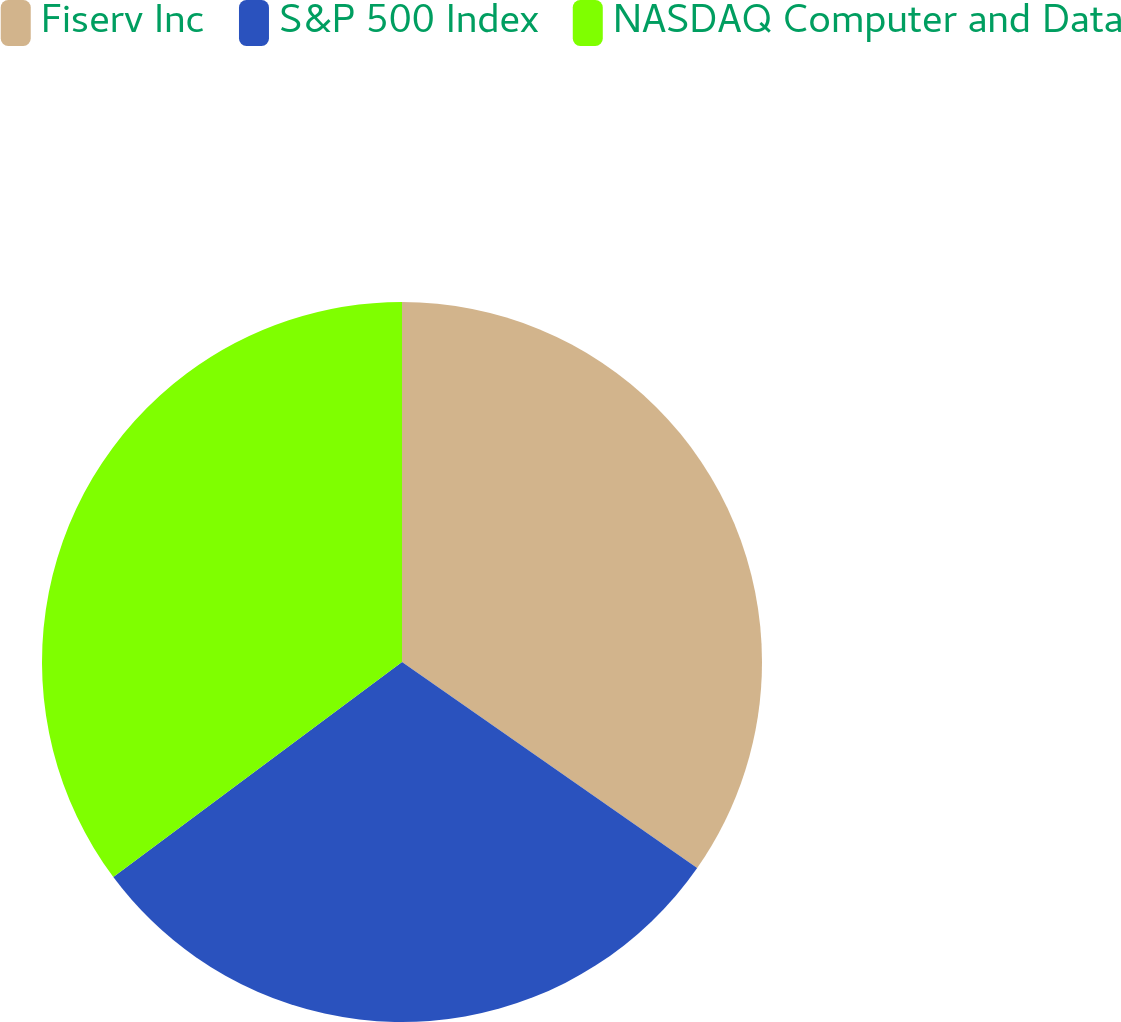<chart> <loc_0><loc_0><loc_500><loc_500><pie_chart><fcel>Fiserv Inc<fcel>S&P 500 Index<fcel>NASDAQ Computer and Data<nl><fcel>34.7%<fcel>30.11%<fcel>35.19%<nl></chart> 